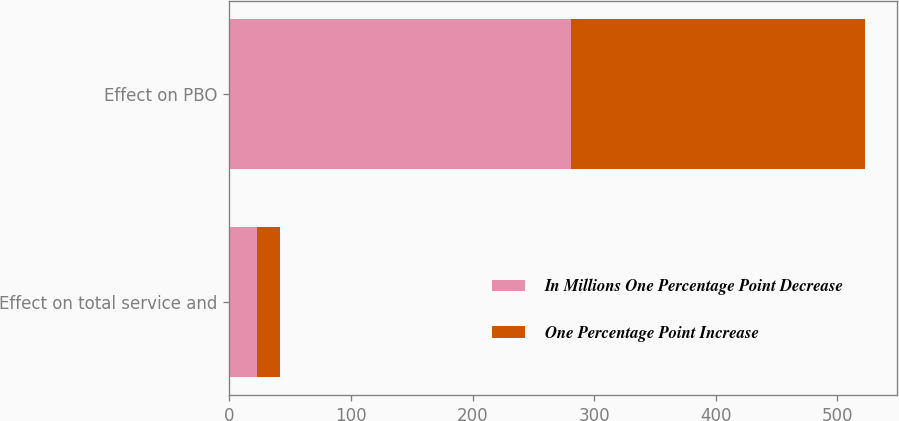Convert chart to OTSL. <chart><loc_0><loc_0><loc_500><loc_500><stacked_bar_chart><ecel><fcel>Effect on total service and<fcel>Effect on PBO<nl><fcel>In Millions One Percentage Point Decrease<fcel>23<fcel>281<nl><fcel>One Percentage Point Increase<fcel>19<fcel>242<nl></chart> 